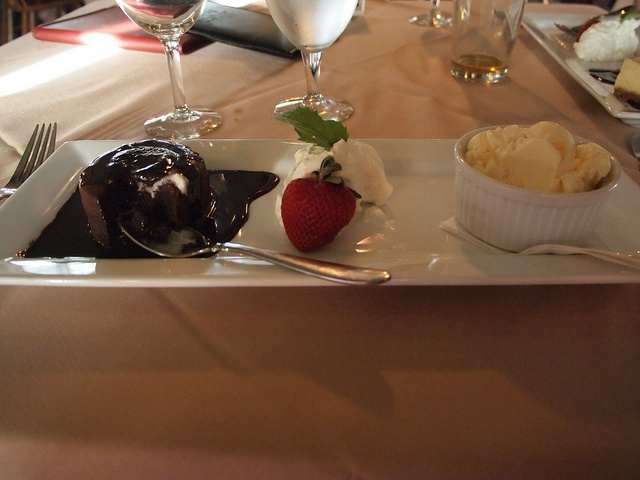Describe the objects in this image and their specific colors. I can see dining table in black, maroon, and gray tones, cake in black, maroon, and gray tones, bowl in black, gray, olive, and maroon tones, cup in black, gray, maroon, brown, and tan tones, and wine glass in black, gray, and tan tones in this image. 